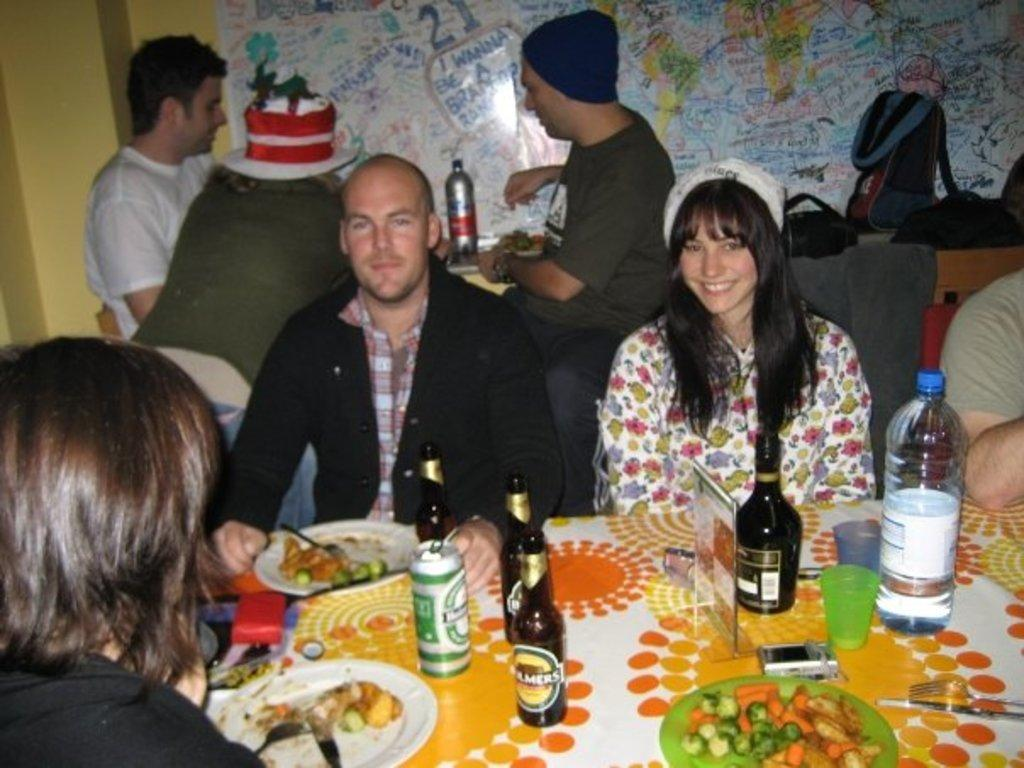How many people are in the image? There is a group of people in the image. What are the people doing in the image? The people are sitting on a chair. Where is the chair located in relation to the table? The chair is in front of a table. What can be seen on the table in the image? There are bottles and other objects on the table. What type of dinner is being served to the beginner in the image? There is no mention of a beginner or dinner in the image; it simply shows a group of people sitting on a chair in front of a table with bottles and other objects. 